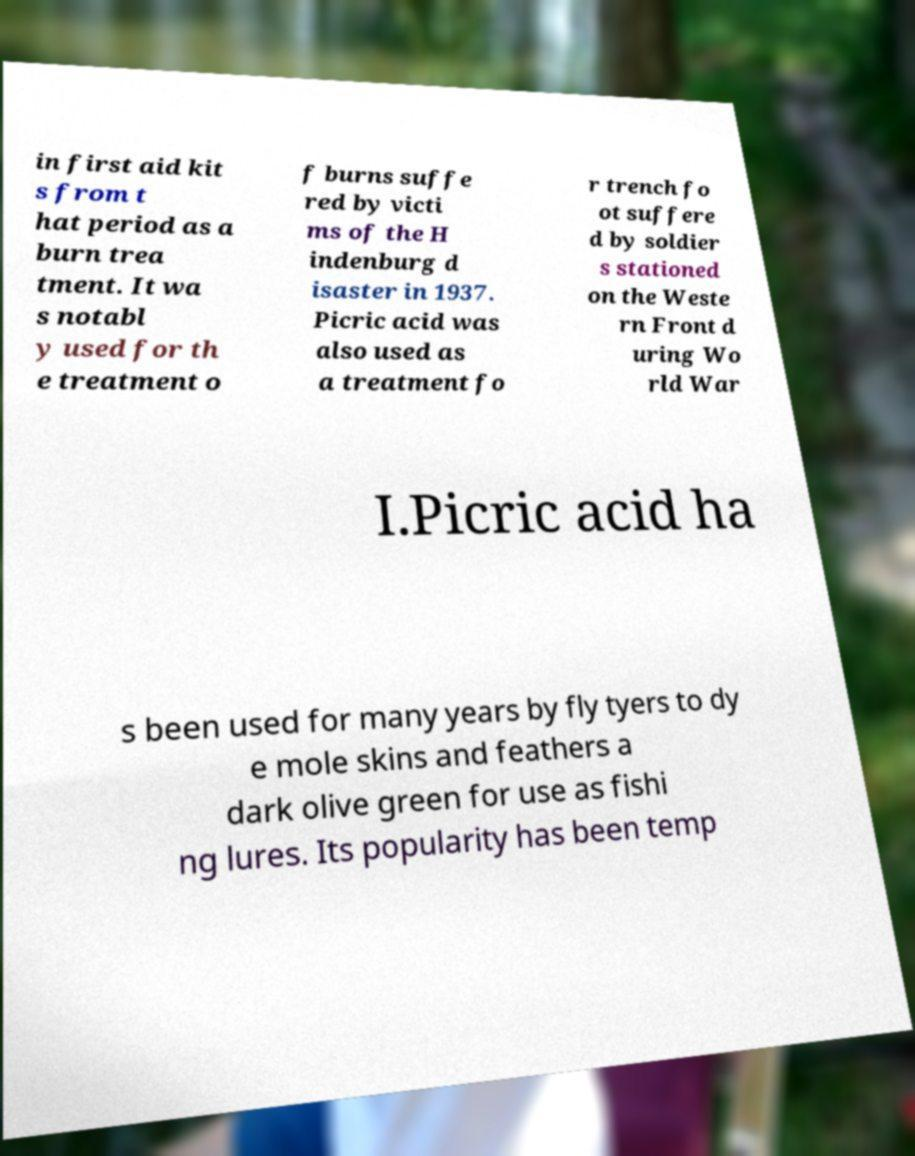Can you accurately transcribe the text from the provided image for me? in first aid kit s from t hat period as a burn trea tment. It wa s notabl y used for th e treatment o f burns suffe red by victi ms of the H indenburg d isaster in 1937. Picric acid was also used as a treatment fo r trench fo ot suffere d by soldier s stationed on the Weste rn Front d uring Wo rld War I.Picric acid ha s been used for many years by fly tyers to dy e mole skins and feathers a dark olive green for use as fishi ng lures. Its popularity has been temp 